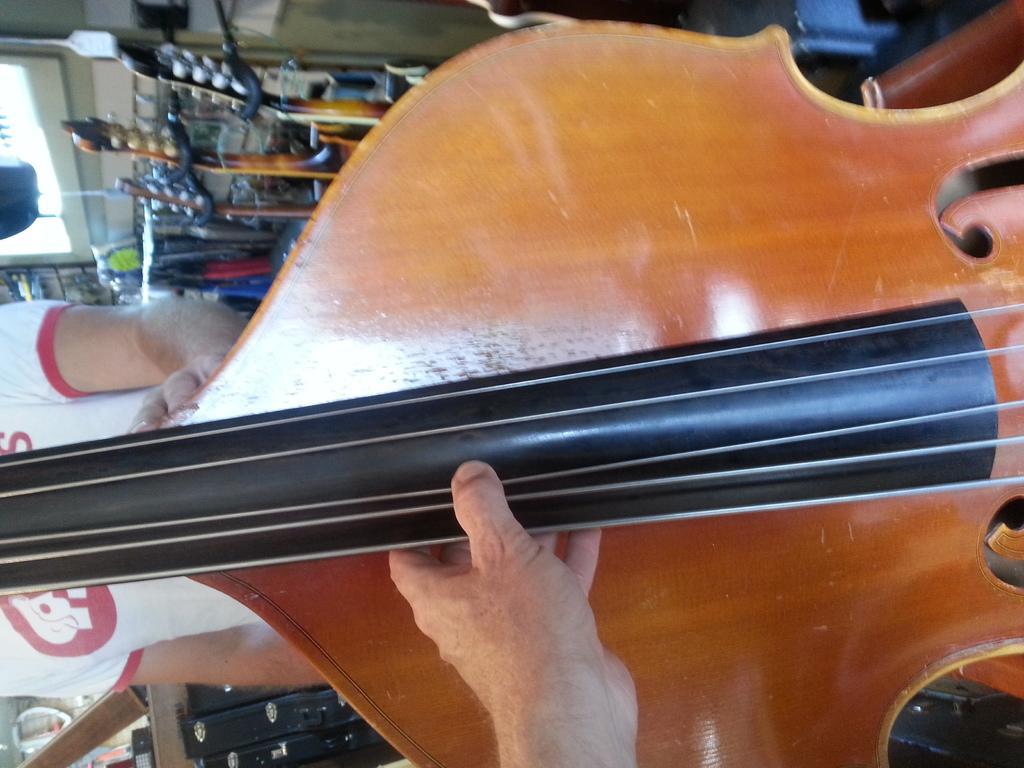How would you summarize this image in a sentence or two? there is a brown and black violin held by a person. behind the violin there is a person standing wearing a white and red t shirt. behind him there are other musical instruments. 